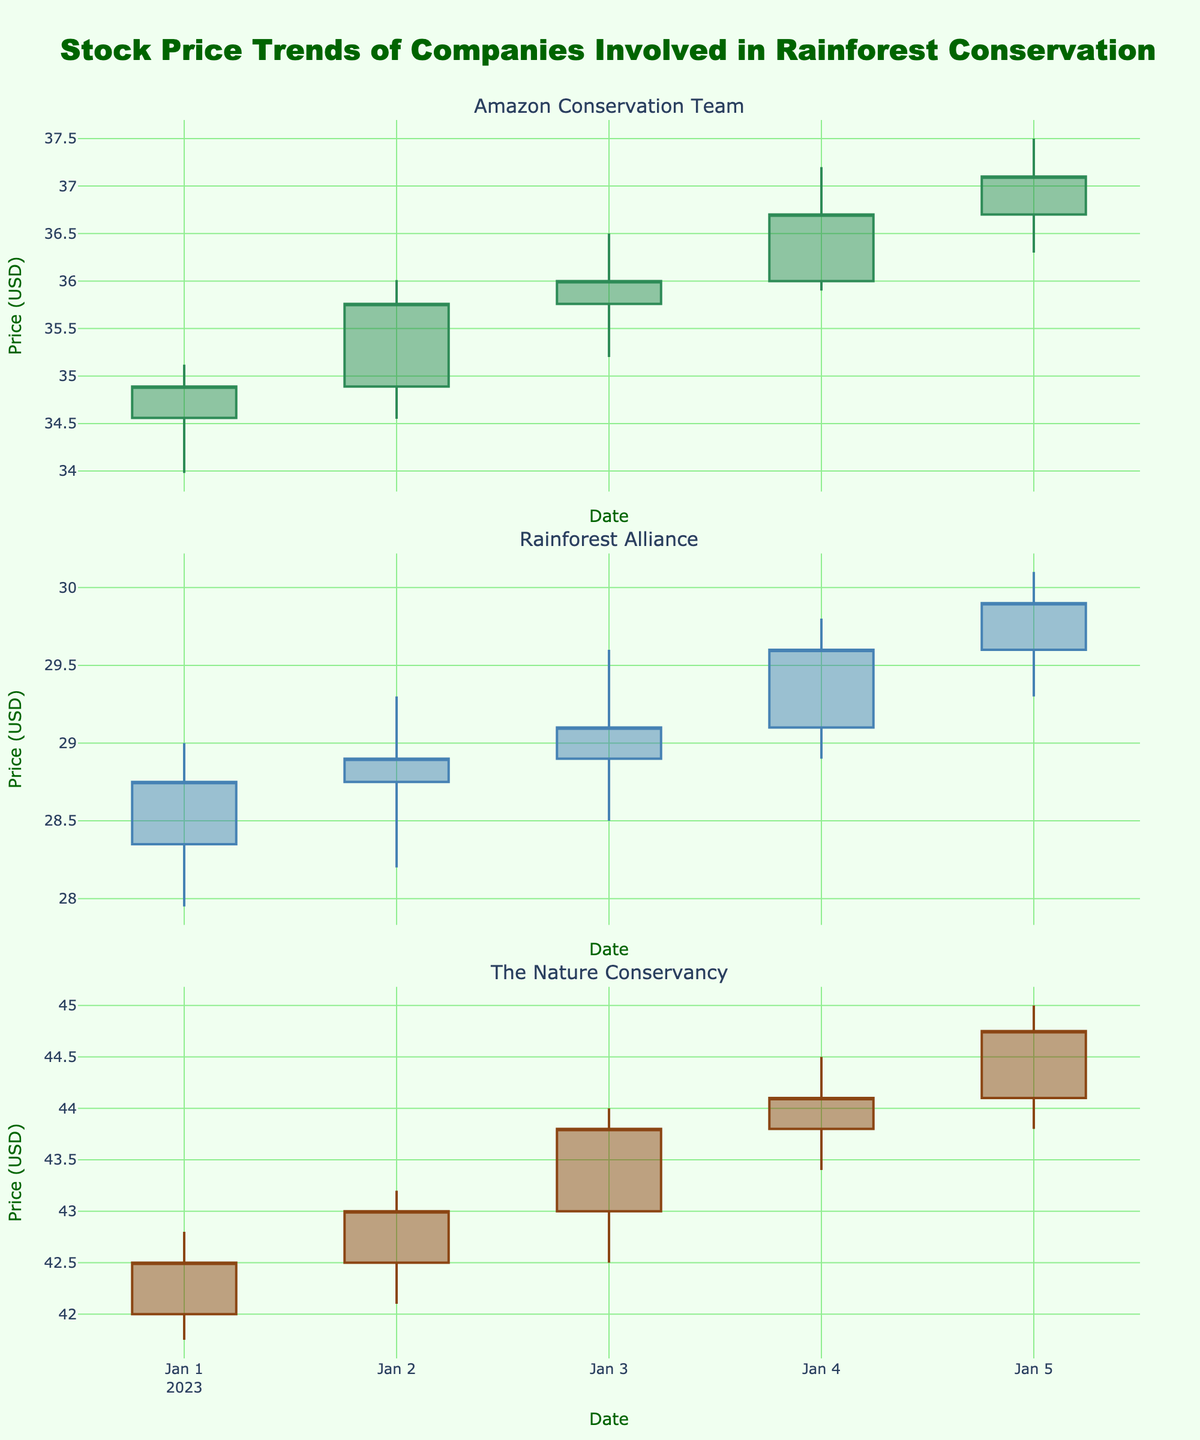What is the highest closing price for The Nature Conservancy? The highest closing price for The Nature Conservancy can be found by looking at the candlestick plot under "The Nature Conservancy" and identifying the highest "Close" value. From the chart, the highest closing price is $44.75.
Answer: $44.75 Which company had the highest trading volume on January 5, 2023? First, identify the trading volumes on January 5 for each company. Amazon Conservation Team had 1,210,000, Rainforest Alliance had 2,690,000, and The Nature Conservancy had 1,910,000. Therefore, Rainforest Alliance had the highest trading volume.
Answer: Rainforest Alliance How many days experienced a closing price higher than the opening price for Amazon Conservation Team? Count the days where the closing price is higher than the opening price for the Amazon Conservation Team by looking at the individual candlesticks where the closing price is higher than the opening price. These days are January 2, 3, 4, and 5, resulting in 4 days.
Answer: 4 Which company exhibited the largest change in closing price from January 1 to January 5? Calculate the change in closing price from January 1 to January 5 for each company. For Amazon Conservation Team, it's 37.10 - 34.89 = 2.21. For Rainforest Alliance, it's 29.90 - 28.75 = 1.15. For The Nature Conservancy, it's 44.75 - 42.50 = 2.25. The largest change is for The Nature Conservancy with 2.25.
Answer: The Nature Conservancy Which day showed the highest trading volume among all companies and what was the volume? Compare the trading volumes across all companies for each day. The highest trading volume is on January 5 for Rainforest Alliance with a volume of 2,690,000.
Answer: January 5, 2,690,000 What is the average closing price for Rainforest Alliance over the 5 days? To find the average closing price, sum the closing prices and divide by the number of days. The closing prices for Rainforest Alliance are 28.75, 28.90, 29.10, 29.60, and 29.90. The total is 146.25 and the average is 146.25 / 5 = 29.25.
Answer: 29.25 On which day did The Nature Conservancy have its lowest intraday low and what was that value? Look for the lowest "Low" price in The Nature Conservancy's candlestick plot. The lowest intraday low is on January 1, at a value of $41.75.
Answer: January 1, $41.75 Did any company experience a consistent increase in closing price across all 5 days? Evaluate each company's closing prices for a consistent increase across all 5 days. Only Amazon Conservation Team and The Nature Conservancy show a general upward trend, but neither consistently increases every day. None of the companies have an unbroken streak.
Answer: No 